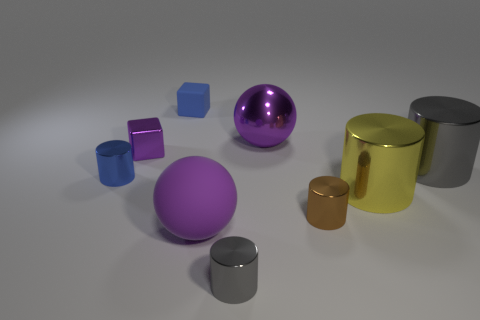Subtract all gray cylinders. How many cylinders are left? 3 Subtract 5 cylinders. How many cylinders are left? 0 Subtract all gray metallic cylinders. Subtract all small objects. How many objects are left? 2 Add 5 tiny gray cylinders. How many tiny gray cylinders are left? 6 Add 6 small rubber cubes. How many small rubber cubes exist? 7 Subtract all yellow cylinders. How many cylinders are left? 4 Subtract 0 brown spheres. How many objects are left? 9 Subtract all cylinders. How many objects are left? 4 Subtract all brown spheres. Subtract all purple cylinders. How many spheres are left? 2 Subtract all blue cylinders. How many gray balls are left? 0 